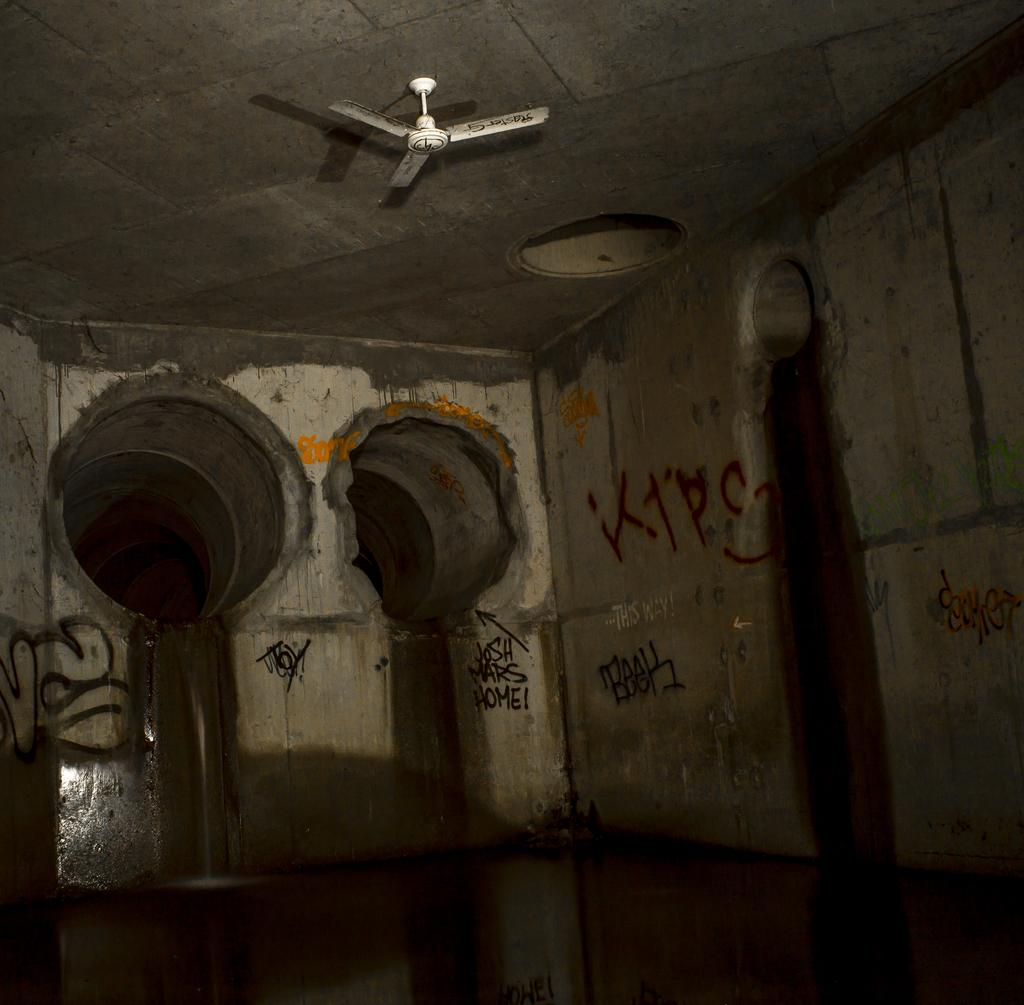What can be seen on the wall in the image? There are two holes in the wall and a fan in white color at the top of the wall. Are there any markings or writings on the wall? Yes, there are names on the wall. How does the card help in adjusting the fan's speed in the image? There is no card present in the image, and therefore no adjustment of the fan's speed can be observed. 